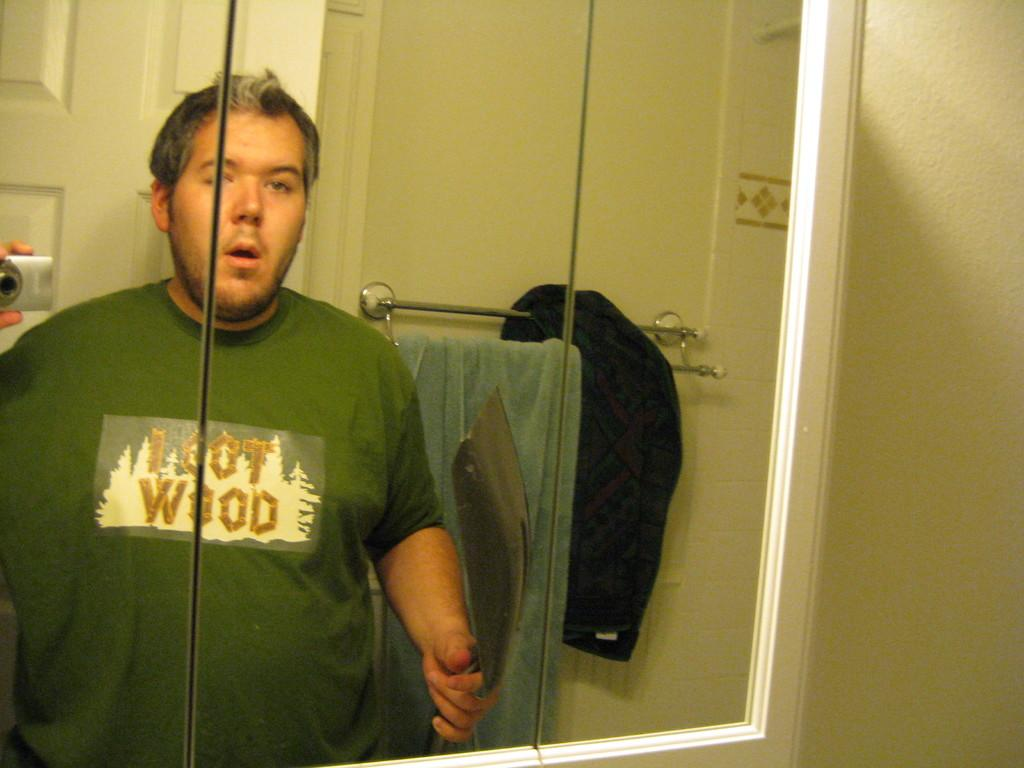Provide a one-sentence caption for the provided image. A man in a loot wood shirt stands in front of a mirror. 